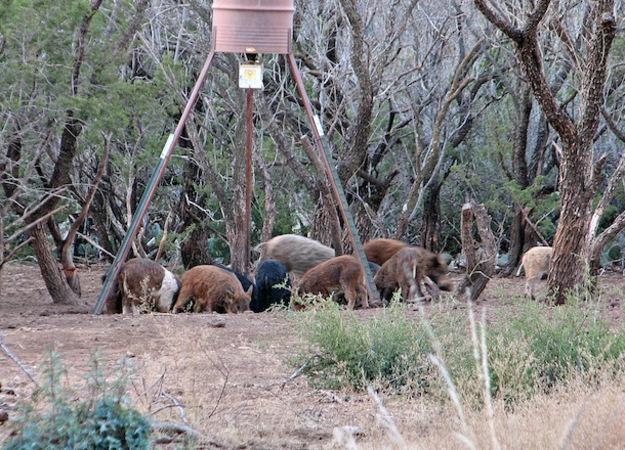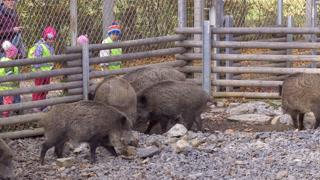The first image is the image on the left, the second image is the image on the right. Examine the images to the left and right. Is the description "there are at most 3 pigs in the image pair" accurate? Answer yes or no. No. The first image is the image on the left, the second image is the image on the right. Given the left and right images, does the statement "In one image there is multiple striped pigs." hold true? Answer yes or no. No. 